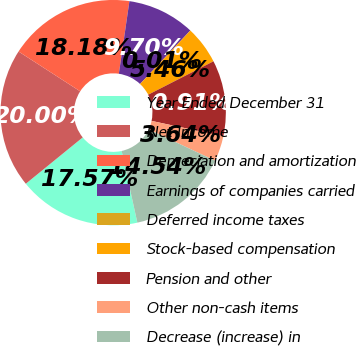Convert chart to OTSL. <chart><loc_0><loc_0><loc_500><loc_500><pie_chart><fcel>Year Ended December 31<fcel>Net Income<fcel>Depreciation and amortization<fcel>Earnings of companies carried<fcel>Deferred income taxes<fcel>Stock-based compensation<fcel>Pension and other<fcel>Other non-cash items<fcel>Decrease (increase) in<nl><fcel>17.57%<fcel>20.0%<fcel>18.18%<fcel>9.7%<fcel>0.01%<fcel>5.46%<fcel>10.91%<fcel>3.64%<fcel>14.54%<nl></chart> 